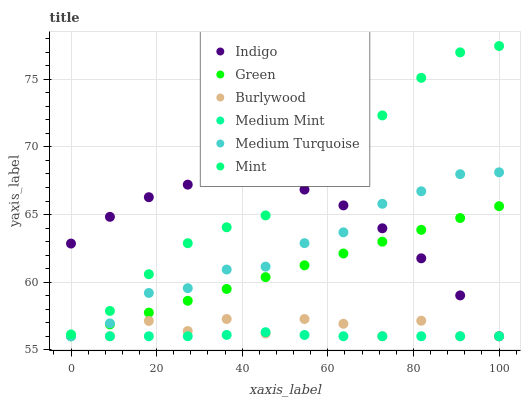Does Medium Mint have the minimum area under the curve?
Answer yes or no. Yes. Does Mint have the maximum area under the curve?
Answer yes or no. Yes. Does Indigo have the minimum area under the curve?
Answer yes or no. No. Does Indigo have the maximum area under the curve?
Answer yes or no. No. Is Green the smoothest?
Answer yes or no. Yes. Is Burlywood the roughest?
Answer yes or no. Yes. Is Indigo the smoothest?
Answer yes or no. No. Is Indigo the roughest?
Answer yes or no. No. Does Medium Mint have the lowest value?
Answer yes or no. Yes. Does Mint have the lowest value?
Answer yes or no. No. Does Mint have the highest value?
Answer yes or no. Yes. Does Indigo have the highest value?
Answer yes or no. No. Is Burlywood less than Mint?
Answer yes or no. Yes. Is Mint greater than Medium Mint?
Answer yes or no. Yes. Does Medium Mint intersect Burlywood?
Answer yes or no. Yes. Is Medium Mint less than Burlywood?
Answer yes or no. No. Is Medium Mint greater than Burlywood?
Answer yes or no. No. Does Burlywood intersect Mint?
Answer yes or no. No. 